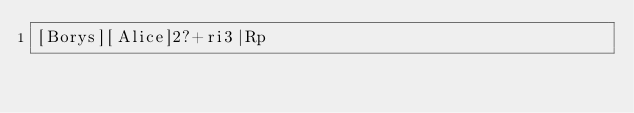Convert code to text. <code><loc_0><loc_0><loc_500><loc_500><_dc_>[Borys][Alice]2?+ri3|Rp</code> 